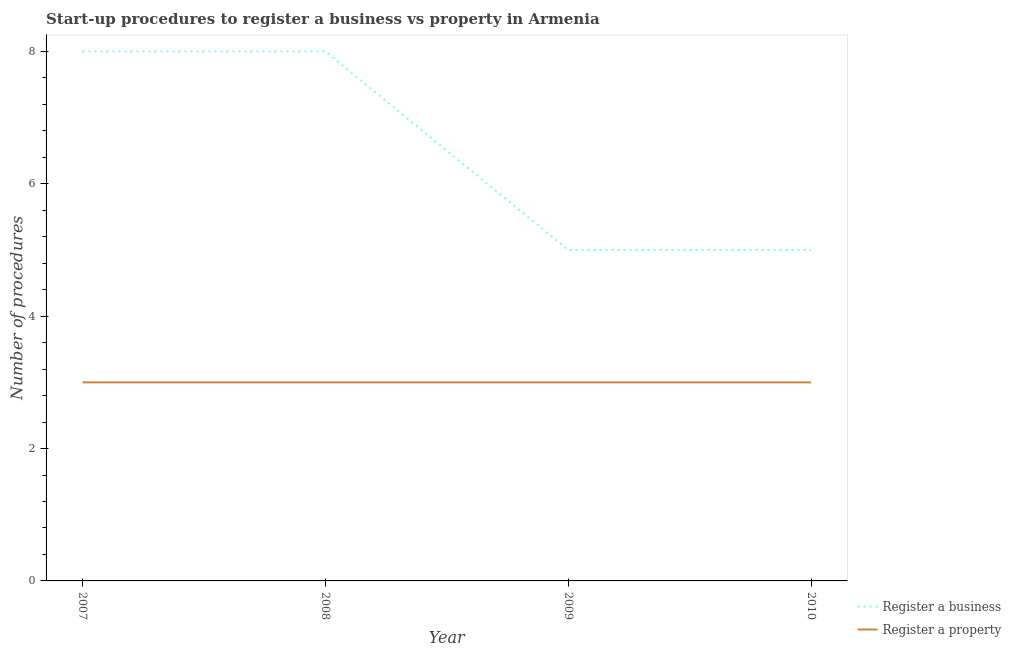How many different coloured lines are there?
Keep it short and to the point. 2. Does the line corresponding to number of procedures to register a property intersect with the line corresponding to number of procedures to register a business?
Your response must be concise. No. Is the number of lines equal to the number of legend labels?
Offer a terse response. Yes. What is the number of procedures to register a business in 2007?
Provide a short and direct response. 8. Across all years, what is the maximum number of procedures to register a property?
Offer a terse response. 3. Across all years, what is the minimum number of procedures to register a business?
Provide a short and direct response. 5. In which year was the number of procedures to register a property minimum?
Your answer should be compact. 2007. What is the total number of procedures to register a business in the graph?
Provide a short and direct response. 26. What is the difference between the number of procedures to register a property in 2007 and the number of procedures to register a business in 2010?
Keep it short and to the point. -2. In the year 2009, what is the difference between the number of procedures to register a business and number of procedures to register a property?
Ensure brevity in your answer.  2. In how many years, is the number of procedures to register a property greater than 6?
Ensure brevity in your answer.  0. What is the ratio of the number of procedures to register a business in 2007 to that in 2010?
Your answer should be very brief. 1.6. Is the number of procedures to register a business in 2007 less than that in 2009?
Give a very brief answer. No. What is the difference between the highest and the lowest number of procedures to register a property?
Provide a short and direct response. 0. In how many years, is the number of procedures to register a property greater than the average number of procedures to register a property taken over all years?
Give a very brief answer. 0. How many lines are there?
Make the answer very short. 2. How many years are there in the graph?
Provide a succinct answer. 4. Are the values on the major ticks of Y-axis written in scientific E-notation?
Your response must be concise. No. How are the legend labels stacked?
Your answer should be compact. Vertical. What is the title of the graph?
Offer a terse response. Start-up procedures to register a business vs property in Armenia. What is the label or title of the X-axis?
Make the answer very short. Year. What is the label or title of the Y-axis?
Provide a short and direct response. Number of procedures. What is the Number of procedures of Register a property in 2007?
Your answer should be very brief. 3. What is the Number of procedures of Register a property in 2008?
Your answer should be compact. 3. What is the Number of procedures in Register a business in 2010?
Offer a terse response. 5. Across all years, what is the maximum Number of procedures of Register a business?
Your response must be concise. 8. Across all years, what is the maximum Number of procedures in Register a property?
Make the answer very short. 3. Across all years, what is the minimum Number of procedures of Register a business?
Your answer should be very brief. 5. Across all years, what is the minimum Number of procedures of Register a property?
Keep it short and to the point. 3. What is the difference between the Number of procedures of Register a business in 2007 and that in 2008?
Offer a terse response. 0. What is the difference between the Number of procedures of Register a property in 2007 and that in 2008?
Provide a short and direct response. 0. What is the difference between the Number of procedures of Register a business in 2007 and that in 2009?
Offer a very short reply. 3. What is the difference between the Number of procedures in Register a property in 2007 and that in 2010?
Provide a short and direct response. 0. What is the difference between the Number of procedures of Register a business in 2008 and that in 2009?
Ensure brevity in your answer.  3. What is the difference between the Number of procedures of Register a property in 2008 and that in 2009?
Provide a succinct answer. 0. What is the difference between the Number of procedures of Register a property in 2008 and that in 2010?
Offer a very short reply. 0. What is the difference between the Number of procedures in Register a business in 2007 and the Number of procedures in Register a property in 2008?
Offer a terse response. 5. What is the difference between the Number of procedures in Register a business in 2007 and the Number of procedures in Register a property in 2010?
Your response must be concise. 5. What is the average Number of procedures of Register a business per year?
Your answer should be very brief. 6.5. In the year 2007, what is the difference between the Number of procedures of Register a business and Number of procedures of Register a property?
Ensure brevity in your answer.  5. In the year 2008, what is the difference between the Number of procedures in Register a business and Number of procedures in Register a property?
Provide a short and direct response. 5. In the year 2009, what is the difference between the Number of procedures of Register a business and Number of procedures of Register a property?
Keep it short and to the point. 2. In the year 2010, what is the difference between the Number of procedures in Register a business and Number of procedures in Register a property?
Ensure brevity in your answer.  2. What is the ratio of the Number of procedures in Register a business in 2007 to that in 2008?
Your answer should be compact. 1. What is the ratio of the Number of procedures in Register a business in 2007 to that in 2009?
Make the answer very short. 1.6. What is the ratio of the Number of procedures of Register a property in 2007 to that in 2009?
Make the answer very short. 1. What is the ratio of the Number of procedures of Register a business in 2008 to that in 2009?
Provide a succinct answer. 1.6. What is the ratio of the Number of procedures of Register a business in 2008 to that in 2010?
Offer a terse response. 1.6. What is the ratio of the Number of procedures in Register a property in 2008 to that in 2010?
Your response must be concise. 1. What is the difference between the highest and the second highest Number of procedures in Register a business?
Offer a terse response. 0. What is the difference between the highest and the lowest Number of procedures in Register a business?
Offer a very short reply. 3. 